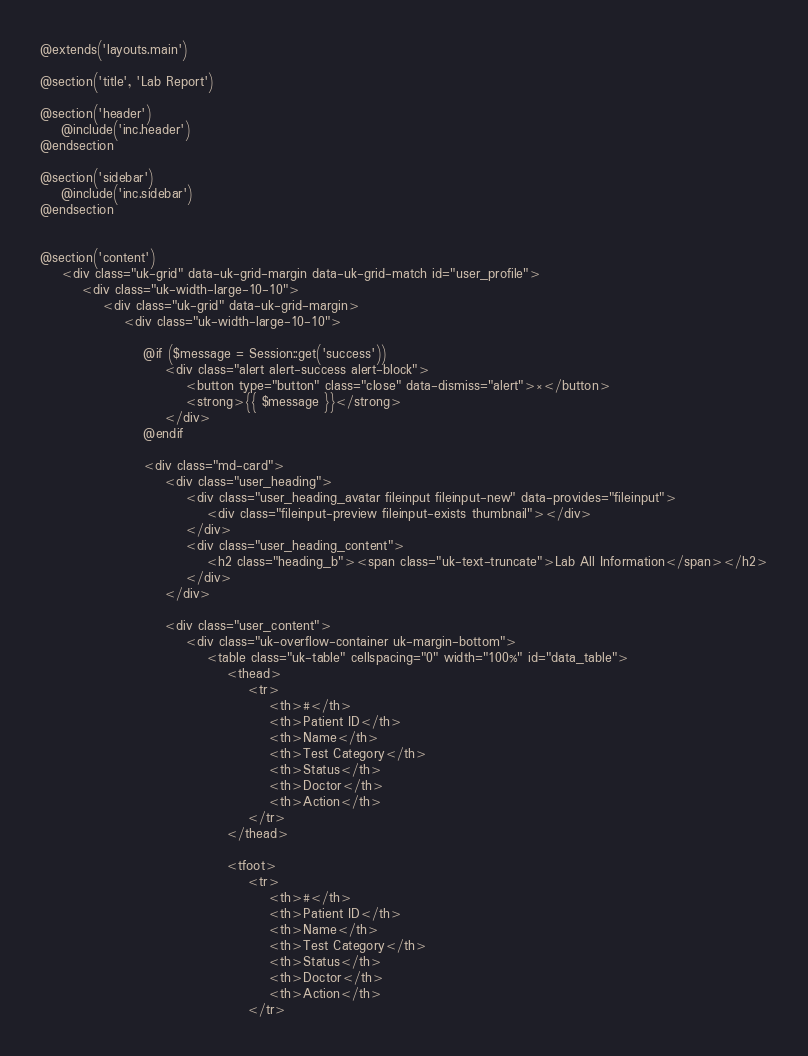<code> <loc_0><loc_0><loc_500><loc_500><_PHP_>@extends('layouts.main')

@section('title', 'Lab Report')

@section('header')
    @include('inc.header')
@endsection

@section('sidebar')
    @include('inc.sidebar')
@endsection


@section('content')
    <div class="uk-grid" data-uk-grid-margin data-uk-grid-match id="user_profile">
        <div class="uk-width-large-10-10">
            <div class="uk-grid" data-uk-grid-margin>
                <div class="uk-width-large-10-10">

                    @if ($message = Session::get('success'))
                        <div class="alert alert-success alert-block">
                            <button type="button" class="close" data-dismiss="alert">×</button>
                            <strong>{{ $message }}</strong>
                        </div>
                    @endif

                    <div class="md-card">
                        <div class="user_heading">
                            <div class="user_heading_avatar fileinput fileinput-new" data-provides="fileinput">
                                <div class="fileinput-preview fileinput-exists thumbnail"></div>
                            </div>
                            <div class="user_heading_content">
                                <h2 class="heading_b"><span class="uk-text-truncate">Lab All Information</span></h2>
                            </div>
                        </div>

                        <div class="user_content">
                            <div class="uk-overflow-container uk-margin-bottom">
                                <table class="uk-table" cellspacing="0" width="100%" id="data_table">
                                    <thead>
                                        <tr>
                                            <th>#</th>
                                            <th>Patient ID</th>
                                            <th>Name</th>
                                            <th>Test Category</th>
                                            <th>Status</th>
                                            <th>Doctor</th>
                                            <th>Action</th>
                                        </tr>
                                    </thead>

                                    <tfoot>
                                        <tr>
                                            <th>#</th>
                                            <th>Patient ID</th>
                                            <th>Name</th>
                                            <th>Test Category</th>
                                            <th>Status</th>
                                            <th>Doctor</th>
                                            <th>Action</th>
                                        </tr></code> 